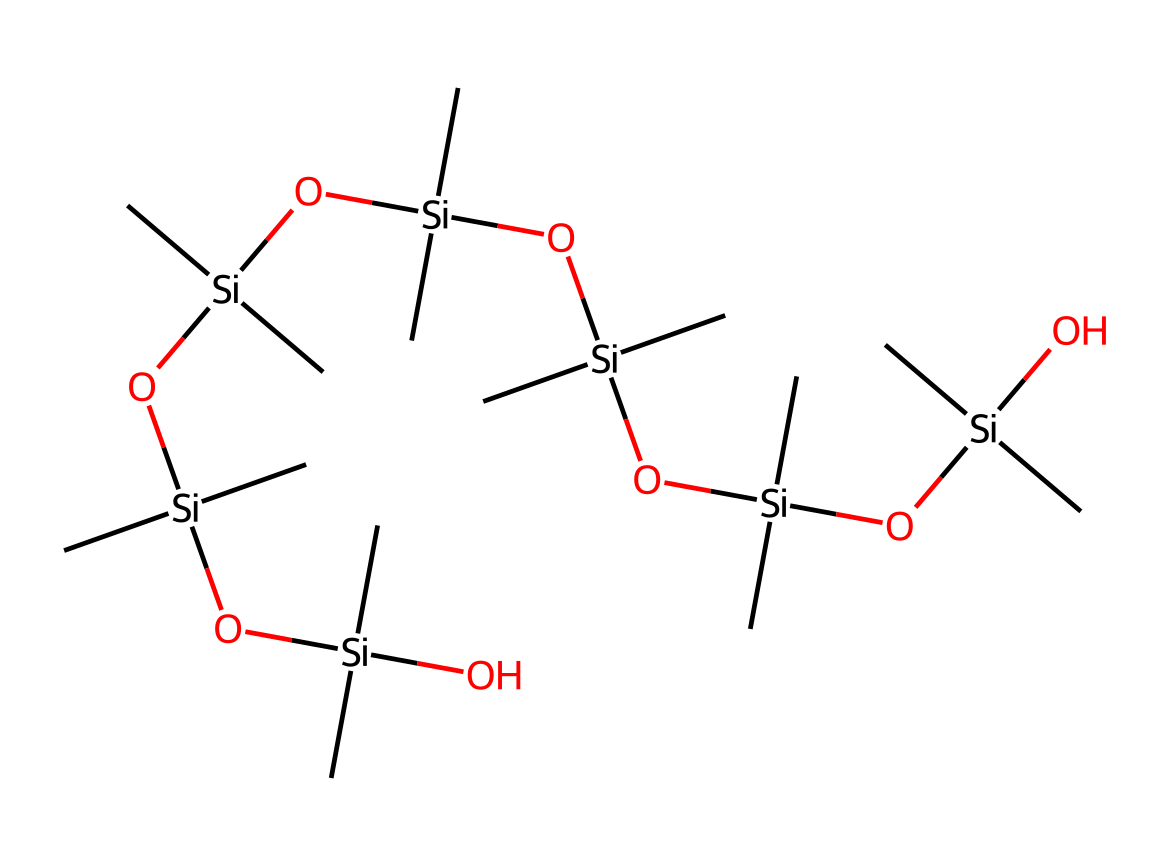What is the chemical name of this compound? The structure indicates it is a type of silicone, commonly referred to as polysiloxane or silicone rubber due to the repeating siloxane (Si-O) units.
Answer: polysiloxane How many silicon atoms are present in the structure? By analyzing the SMILES representation, we can identify that there are multiple silicon atoms indicated by the 'Si' notation. Counting each 'Si' gives a total of six silicon atoms.
Answer: six What type of bonds connect the silicon atoms in this compound? The structure contains Si-O bonds, which are characteristic of siloxanes. We can deduce this from the repeated 'O[Si]' parts in the SMILES representation indicating connectivity via oxygen atoms.
Answer: Si-O What are the main functional groups present in this silicone compound? The structure implies the presence of hydroxyl (OH) groups and alkyl groups attached to the silicon atoms, observable from the presence of 'O' and 'C' elements in conjunction with 'Si'.
Answer: hydroxyl and alkyl Why is this compound used in making dampeners for studio headphones? The flexibility and resilience of the silicone rubber matrix from its organosilicon structure allow it to absorb vibrations effectively, which is essential for damping sound vibrations in headphones.
Answer: flexibility and resilience How many carbon atoms are present in the compound? The SMILES representation shows that carbon atoms are part of the alkyl groups connected to the silicon atoms. Counting each 'C' in the representation reveals there are 18 carbon atoms.
Answer: eighteen 